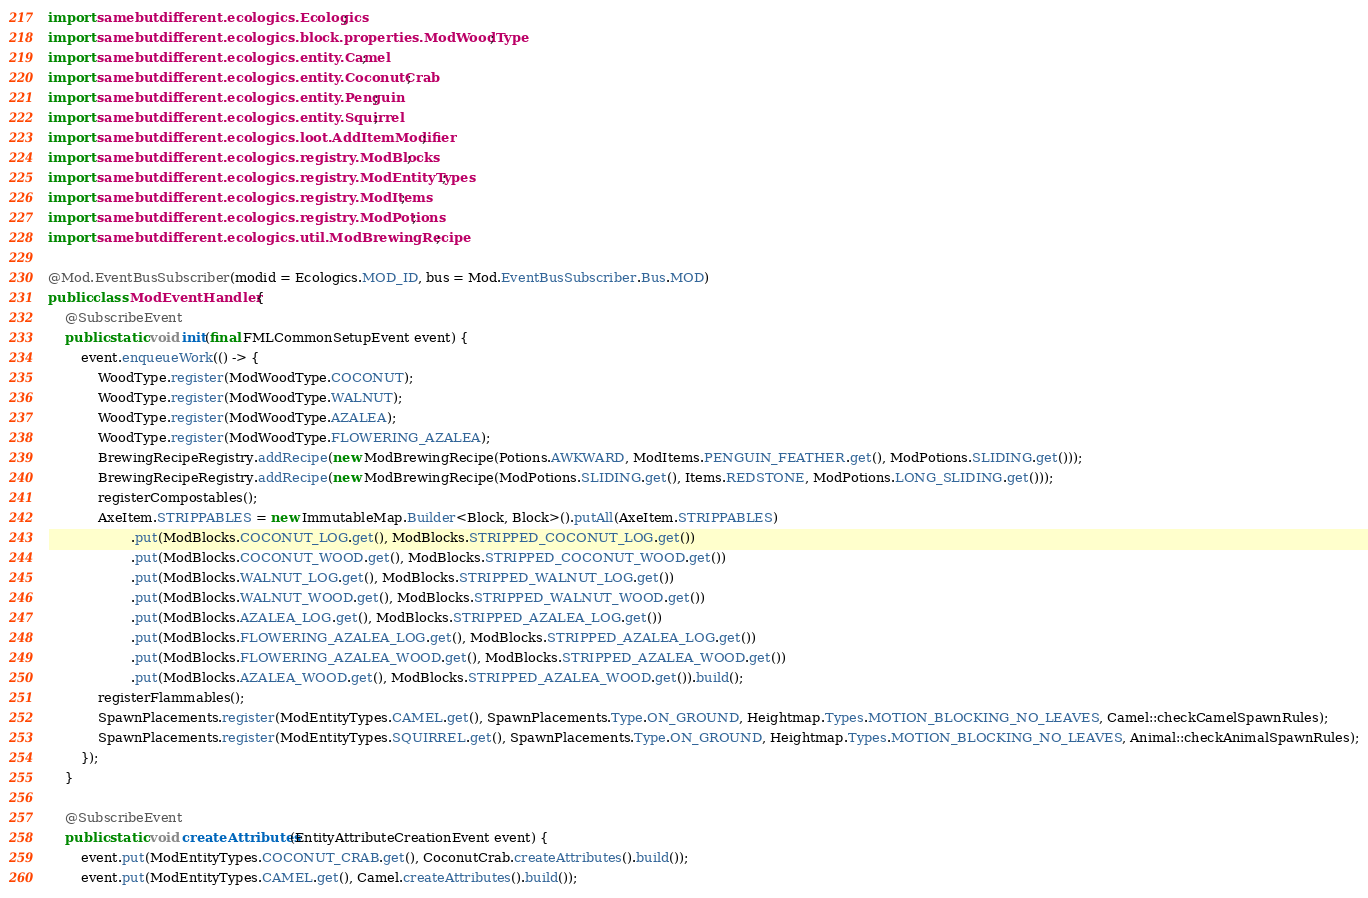<code> <loc_0><loc_0><loc_500><loc_500><_Java_>import samebutdifferent.ecologics.Ecologics;
import samebutdifferent.ecologics.block.properties.ModWoodType;
import samebutdifferent.ecologics.entity.Camel;
import samebutdifferent.ecologics.entity.CoconutCrab;
import samebutdifferent.ecologics.entity.Penguin;
import samebutdifferent.ecologics.entity.Squirrel;
import samebutdifferent.ecologics.loot.AddItemModifier;
import samebutdifferent.ecologics.registry.ModBlocks;
import samebutdifferent.ecologics.registry.ModEntityTypes;
import samebutdifferent.ecologics.registry.ModItems;
import samebutdifferent.ecologics.registry.ModPotions;
import samebutdifferent.ecologics.util.ModBrewingRecipe;

@Mod.EventBusSubscriber(modid = Ecologics.MOD_ID, bus = Mod.EventBusSubscriber.Bus.MOD)
public class ModEventHandler {
    @SubscribeEvent
    public static void init(final FMLCommonSetupEvent event) {
        event.enqueueWork(() -> {
            WoodType.register(ModWoodType.COCONUT);
            WoodType.register(ModWoodType.WALNUT);
            WoodType.register(ModWoodType.AZALEA);
            WoodType.register(ModWoodType.FLOWERING_AZALEA);
            BrewingRecipeRegistry.addRecipe(new ModBrewingRecipe(Potions.AWKWARD, ModItems.PENGUIN_FEATHER.get(), ModPotions.SLIDING.get()));
            BrewingRecipeRegistry.addRecipe(new ModBrewingRecipe(ModPotions.SLIDING.get(), Items.REDSTONE, ModPotions.LONG_SLIDING.get()));
            registerCompostables();
            AxeItem.STRIPPABLES = new ImmutableMap.Builder<Block, Block>().putAll(AxeItem.STRIPPABLES)
                    .put(ModBlocks.COCONUT_LOG.get(), ModBlocks.STRIPPED_COCONUT_LOG.get())
                    .put(ModBlocks.COCONUT_WOOD.get(), ModBlocks.STRIPPED_COCONUT_WOOD.get())
                    .put(ModBlocks.WALNUT_LOG.get(), ModBlocks.STRIPPED_WALNUT_LOG.get())
                    .put(ModBlocks.WALNUT_WOOD.get(), ModBlocks.STRIPPED_WALNUT_WOOD.get())
                    .put(ModBlocks.AZALEA_LOG.get(), ModBlocks.STRIPPED_AZALEA_LOG.get())
                    .put(ModBlocks.FLOWERING_AZALEA_LOG.get(), ModBlocks.STRIPPED_AZALEA_LOG.get())
                    .put(ModBlocks.FLOWERING_AZALEA_WOOD.get(), ModBlocks.STRIPPED_AZALEA_WOOD.get())
                    .put(ModBlocks.AZALEA_WOOD.get(), ModBlocks.STRIPPED_AZALEA_WOOD.get()).build();
            registerFlammables();
            SpawnPlacements.register(ModEntityTypes.CAMEL.get(), SpawnPlacements.Type.ON_GROUND, Heightmap.Types.MOTION_BLOCKING_NO_LEAVES, Camel::checkCamelSpawnRules);
            SpawnPlacements.register(ModEntityTypes.SQUIRREL.get(), SpawnPlacements.Type.ON_GROUND, Heightmap.Types.MOTION_BLOCKING_NO_LEAVES, Animal::checkAnimalSpawnRules);
        });
    }

    @SubscribeEvent
    public static void createAttributes(EntityAttributeCreationEvent event) {
        event.put(ModEntityTypes.COCONUT_CRAB.get(), CoconutCrab.createAttributes().build());
        event.put(ModEntityTypes.CAMEL.get(), Camel.createAttributes().build());</code> 